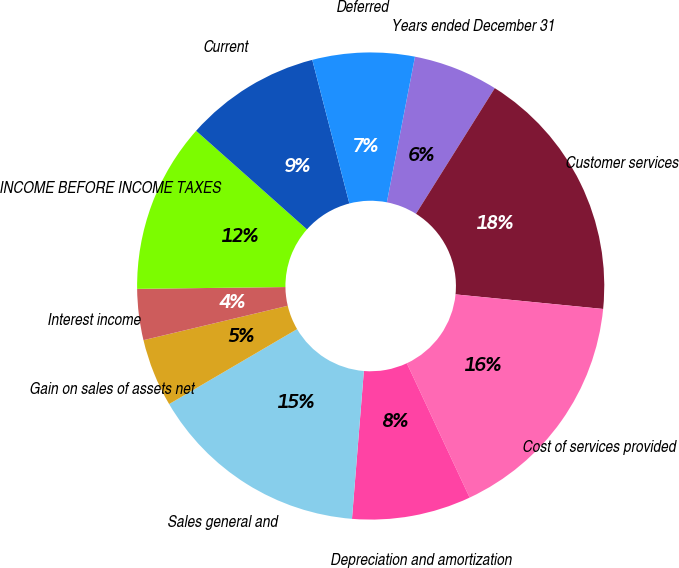<chart> <loc_0><loc_0><loc_500><loc_500><pie_chart><fcel>Years ended December 31<fcel>Customer services<fcel>Cost of services provided<fcel>Depreciation and amortization<fcel>Sales general and<fcel>Gain on sales of assets net<fcel>Interest income<fcel>INCOME BEFORE INCOME TAXES<fcel>Current<fcel>Deferred<nl><fcel>5.88%<fcel>17.65%<fcel>16.47%<fcel>8.24%<fcel>15.29%<fcel>4.71%<fcel>3.53%<fcel>11.76%<fcel>9.41%<fcel>7.06%<nl></chart> 